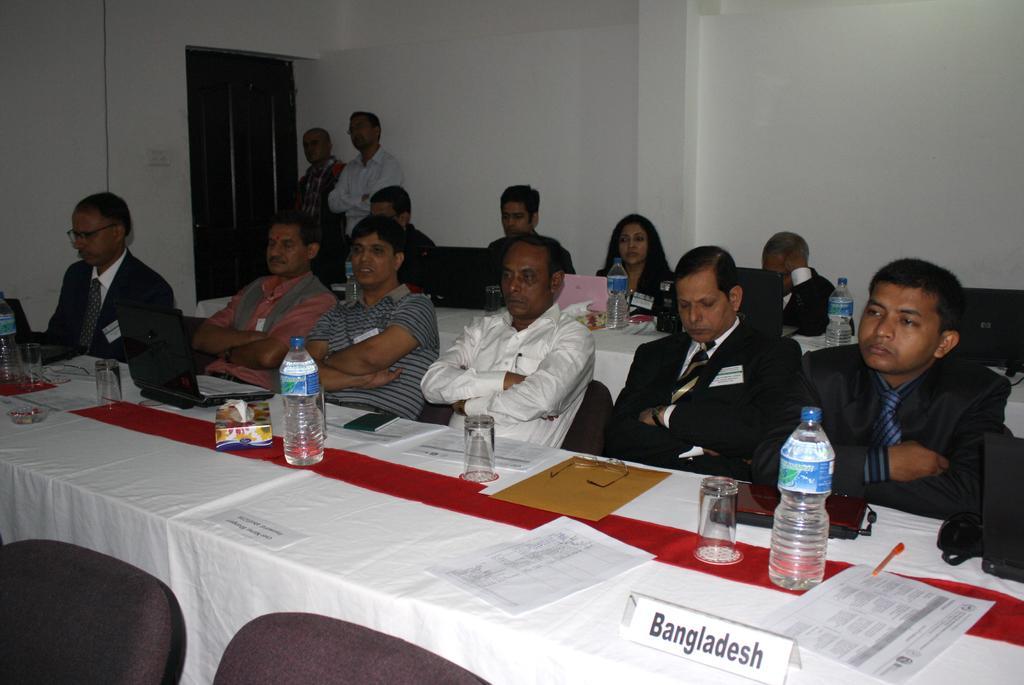Could you give a brief overview of what you see in this image? There is a room with one window in which tables and chairs are arranged in row. people are sitting in the chairs and in second row one female is sitting. there are two people standing near the window there are so many papers and water bottles along with glasses are arranged on table. along with tissue box, and also there is name board of the state Bangladesh on the table. 